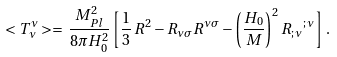Convert formula to latex. <formula><loc_0><loc_0><loc_500><loc_500>< T ^ { \nu } _ { \nu } > = \, \frac { M _ { P l } ^ { 2 } } { 8 \pi H _ { 0 } ^ { 2 } } \left [ \frac { 1 } { 3 } \, R ^ { 2 } - R _ { \nu \sigma } R ^ { \nu \sigma } - \left ( \frac { H _ { 0 } } { M } \right ) ^ { 2 } { R _ { ; \, \nu } } ^ { ; \, \nu } \right ] \, .</formula> 